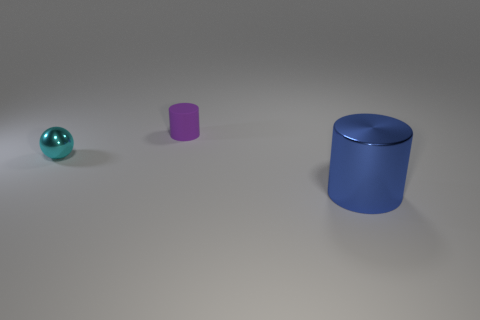Add 1 metallic spheres. How many objects exist? 4 Subtract all spheres. How many objects are left? 2 Subtract all blue matte cylinders. Subtract all small purple cylinders. How many objects are left? 2 Add 2 small cyan metallic objects. How many small cyan metallic objects are left? 3 Add 2 cyan metal spheres. How many cyan metal spheres exist? 3 Subtract 0 brown cylinders. How many objects are left? 3 